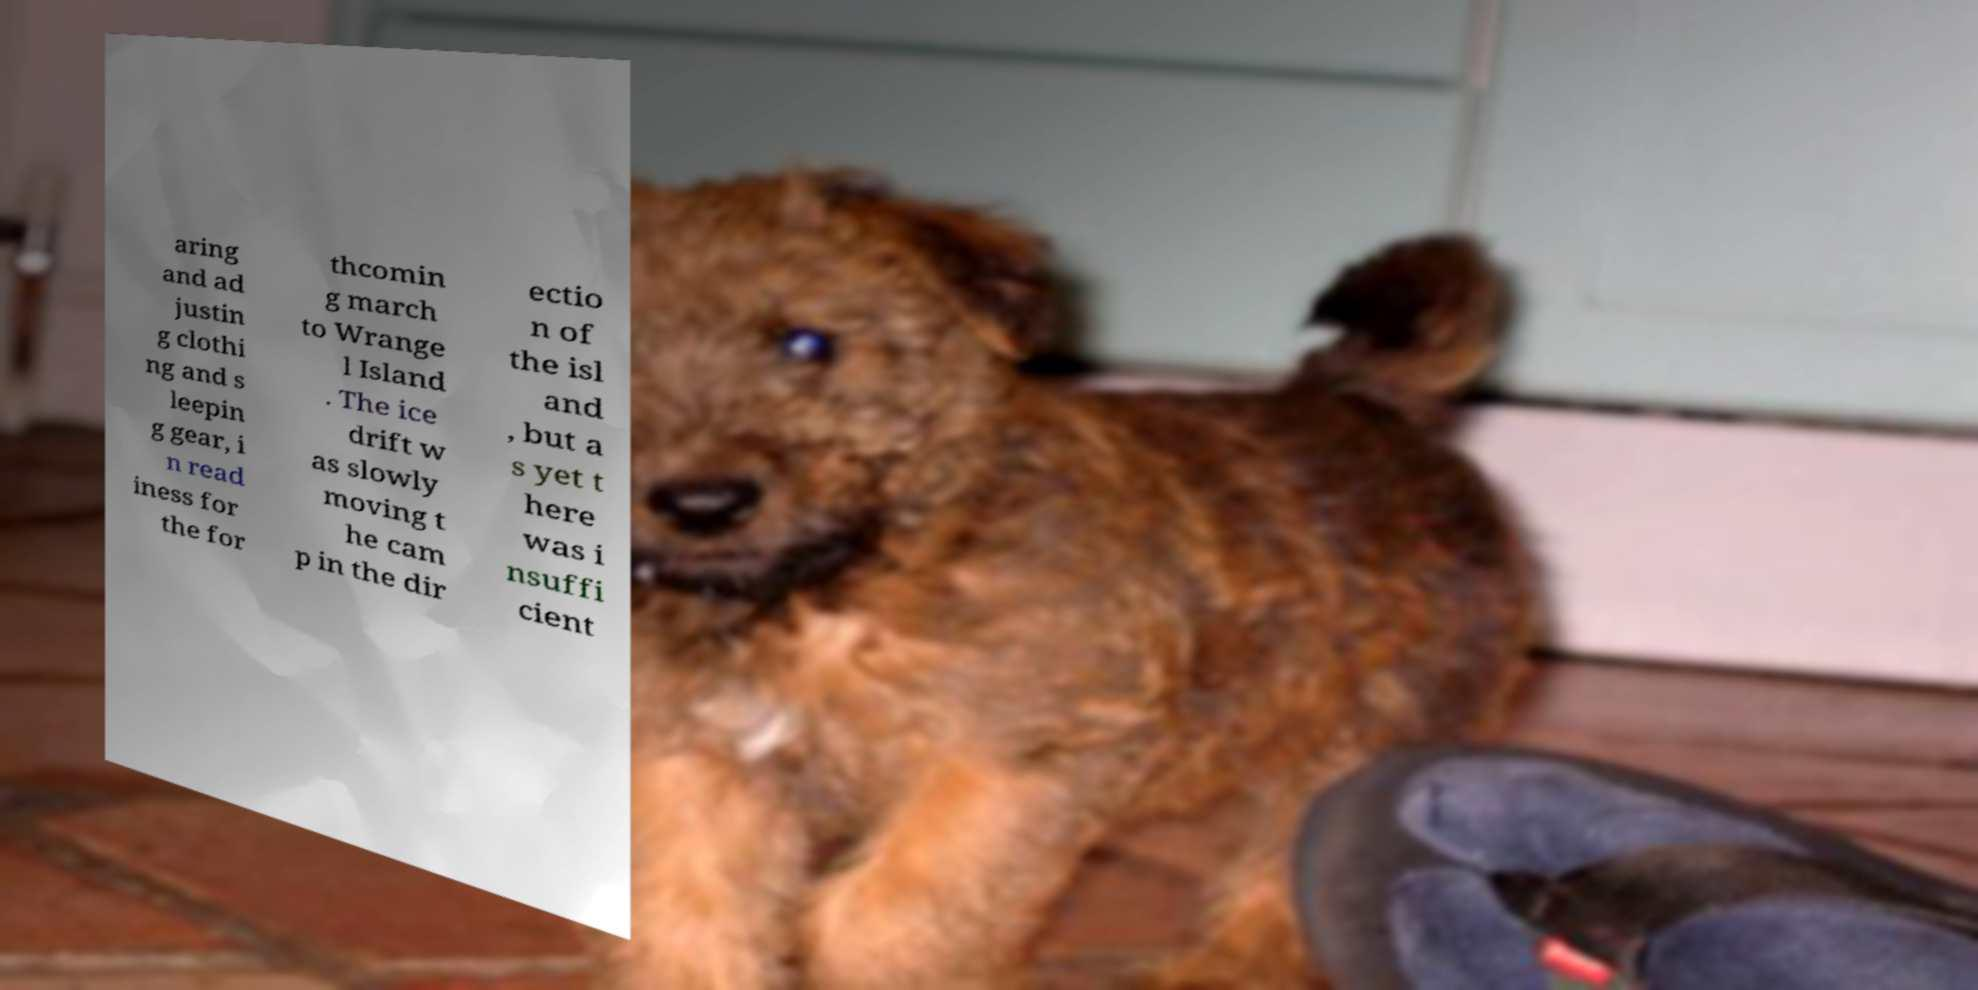Can you accurately transcribe the text from the provided image for me? aring and ad justin g clothi ng and s leepin g gear, i n read iness for the for thcomin g march to Wrange l Island . The ice drift w as slowly moving t he cam p in the dir ectio n of the isl and , but a s yet t here was i nsuffi cient 